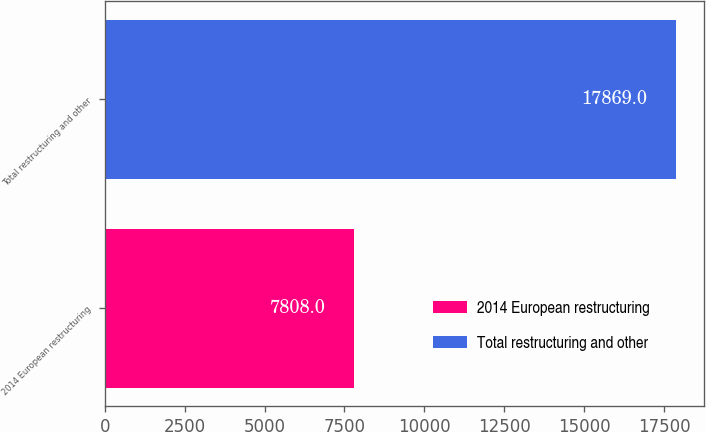Convert chart to OTSL. <chart><loc_0><loc_0><loc_500><loc_500><bar_chart><fcel>2014 European restructuring<fcel>Total restructuring and other<nl><fcel>7808<fcel>17869<nl></chart> 